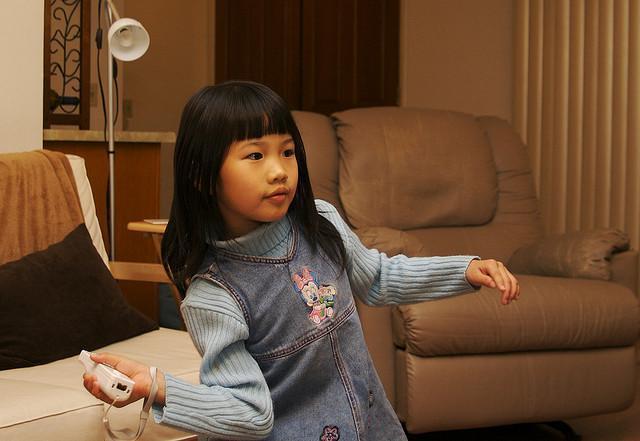Verify the accuracy of this image caption: "The person is in the couch.".
Answer yes or no. No. 